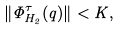Convert formula to latex. <formula><loc_0><loc_0><loc_500><loc_500>\| \Phi _ { H _ { 2 } } ^ { \tau } ( q ) \| < K ,</formula> 